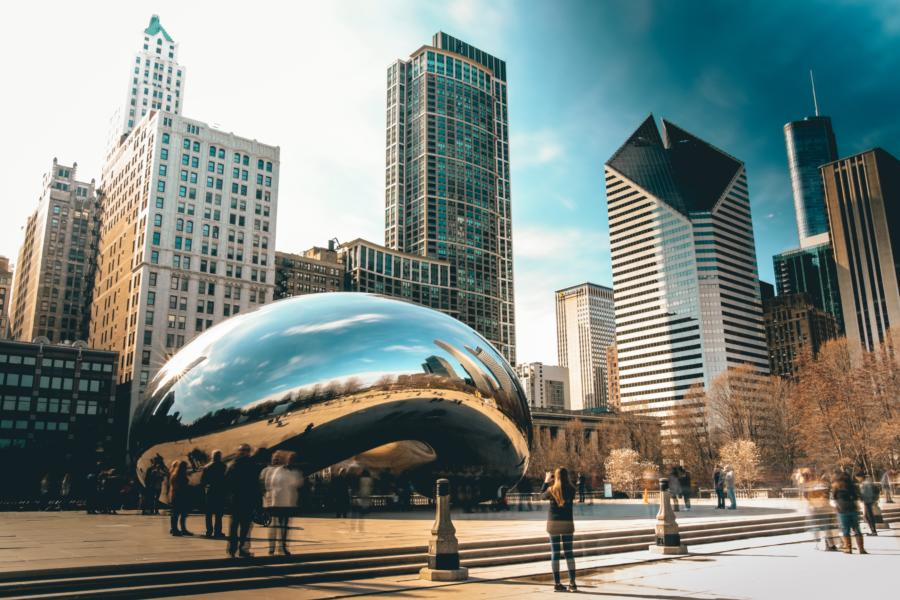How does Cloud Gate interact with its environment in terms of design and functionality? Cloud Gate's design serves multiple purposes, blending art with public space functionality. The elliptical shape and reflective material invite visitors to view both themselves and the skyscape of the city from numerous perspectives, engaging with the sculpture by walking around and under it. This interaction transforms the space into a lively, communal area, emphasizing urban connectivity through art. 